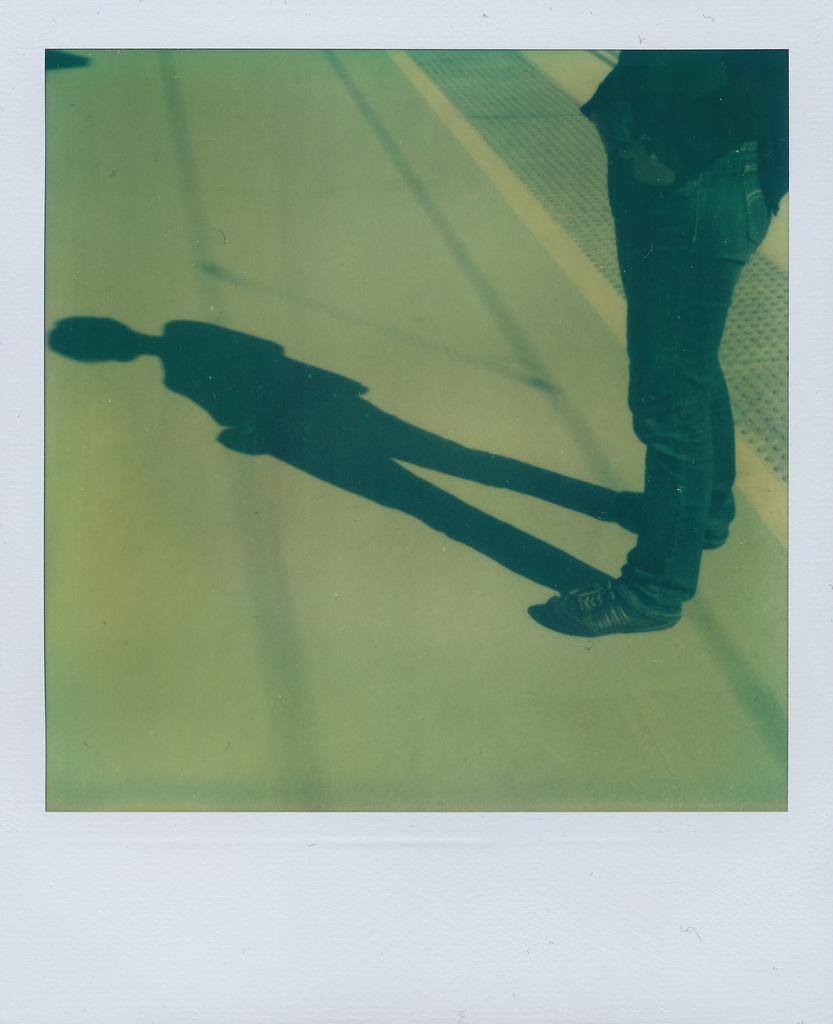Can you describe this image briefly? In this image we can see the photograph of a person standing on the road. 